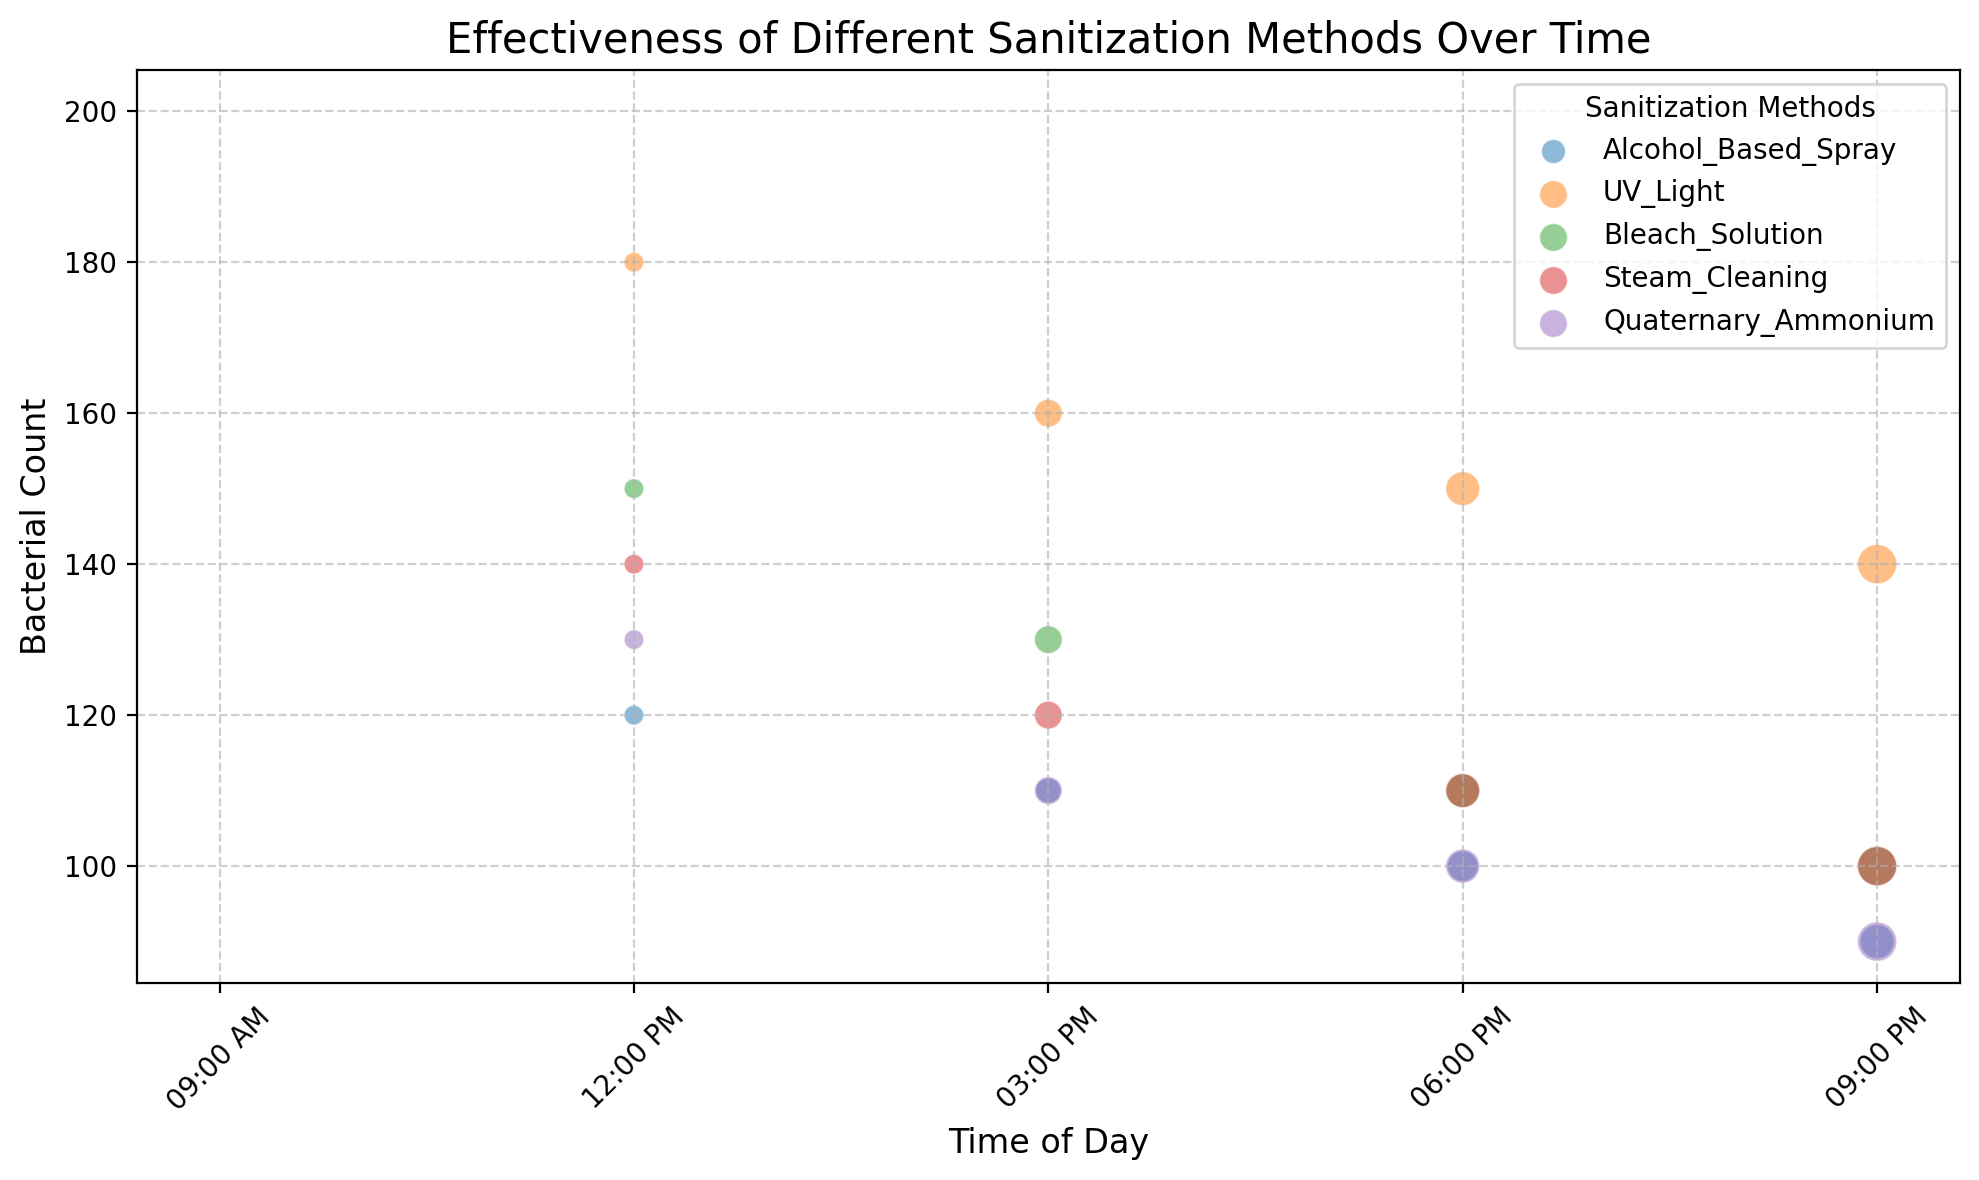Which sanitization method has the lowest bacterial count at 09:00 PM? The chart shows the bacterial count for each sanitization method at different times. At 09:00 PM, the lowest bacterial count can be placed by comparing the values of all methods.
Answer: Alcohol_Based_Spray and Quaternary_Ammonium What is the trend observed in the bacterial count for UV Light throughout the day? By looking at the scatter points for UV Light, one can observe how the bacterial count changes over time by comparing the counts at different times. It starts high in the morning and gradually decreases as the day progresses.
Answer: The bacterial count decreases Which sanitization method shows the highest effectiveness score at 03:00 PM? To find this, compare the effectiveness scores at 03:00 PM for all sanitization methods displayed on the chart.
Answer: Alcohol_Based_Spray Compare the effectiveness scores of Bleach Solution and Steam Cleaning at 06:00 PM. Which one is higher? Check the effectiveness score for both Bleach Solution and Steam Cleaning at 06:00 PM and compare them.
Answer: Bleach Solution Across all methods, which time of the day generally shows the lowest bacterial counts? By observing the scatter plot, identify the time of day that consistently shows the lowest bacterial counts across different sanitization methods.
Answer: 09:00 PM What is the relationship between the size of the bubbles and the effectiveness score? The size of the bubbles is correlated to the effectiveness score, with larger bubbles indicating higher effectiveness. This can be inferred by comparing bubble sizes.
Answer: Larger bubbles indicate higher effectiveness Is there any method whose effectiveness score does not increase significantly throughout the day? By tracing the effectiveness scores for each sanitization method over time, identify if any method shows minimal change.
Answer: UV Light Compare the bacterial counts of Quaternary Ammonium and Steam Cleaning at 12:00 PM. Which method exhibits a lower count? Look at the bacterial counts at 12:00 PM for both methods and determine which count is lower.
Answer: Quaternary Ammonium What can be inferred about the trend of Alcohol-Based Spray's effectiveness score throughout the day? By looking at the scatter points for Alcohol-Based Spray, one can see how the effectiveness score changes over time. It rises from 09:00 AM to 09:00 PM.
Answer: It increases 